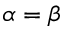<formula> <loc_0><loc_0><loc_500><loc_500>\alpha = \beta</formula> 